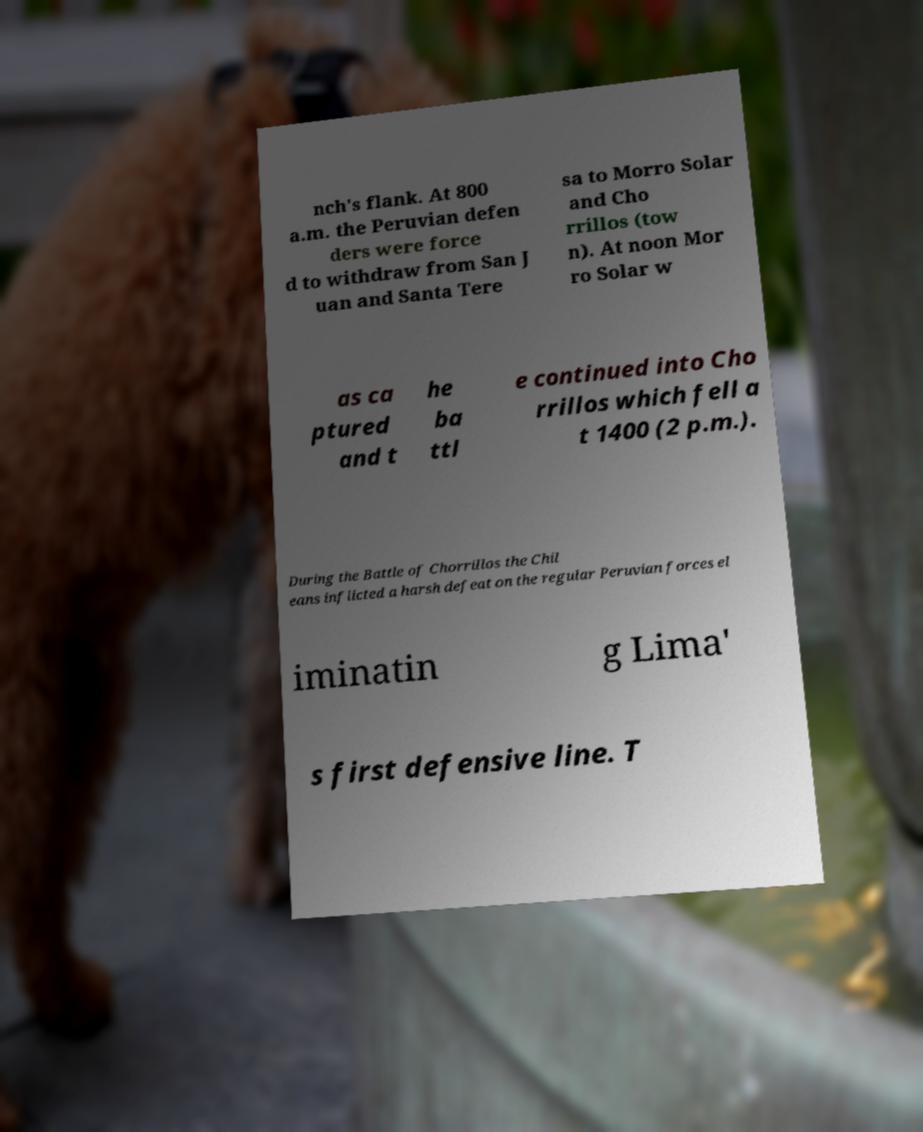Please identify and transcribe the text found in this image. nch's flank. At 800 a.m. the Peruvian defen ders were force d to withdraw from San J uan and Santa Tere sa to Morro Solar and Cho rrillos (tow n). At noon Mor ro Solar w as ca ptured and t he ba ttl e continued into Cho rrillos which fell a t 1400 (2 p.m.). During the Battle of Chorrillos the Chil eans inflicted a harsh defeat on the regular Peruvian forces el iminatin g Lima' s first defensive line. T 